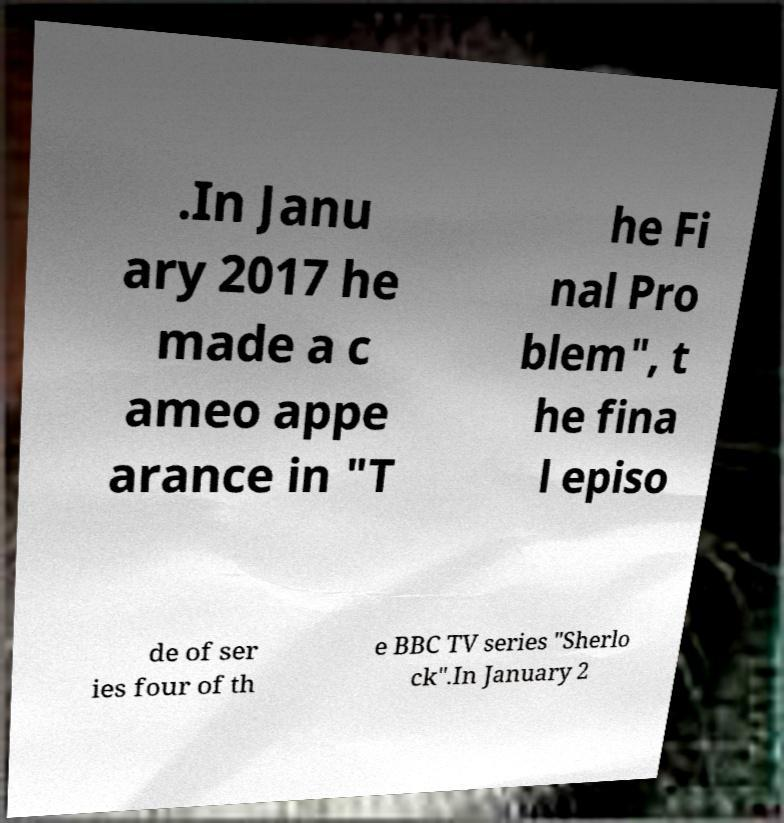Please read and relay the text visible in this image. What does it say? .In Janu ary 2017 he made a c ameo appe arance in "T he Fi nal Pro blem", t he fina l episo de of ser ies four of th e BBC TV series "Sherlo ck".In January 2 